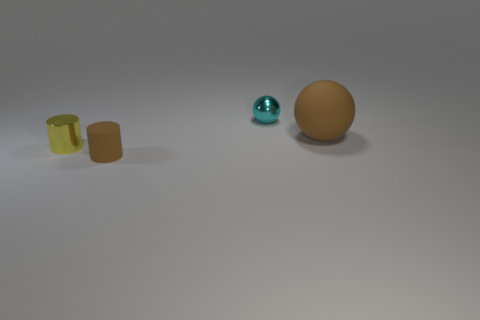Add 2 tiny blue cylinders. How many objects exist? 6 Add 3 big brown balls. How many big brown balls are left? 4 Add 2 matte balls. How many matte balls exist? 3 Subtract 0 gray cylinders. How many objects are left? 4 Subtract all large blue cylinders. Subtract all tiny brown objects. How many objects are left? 3 